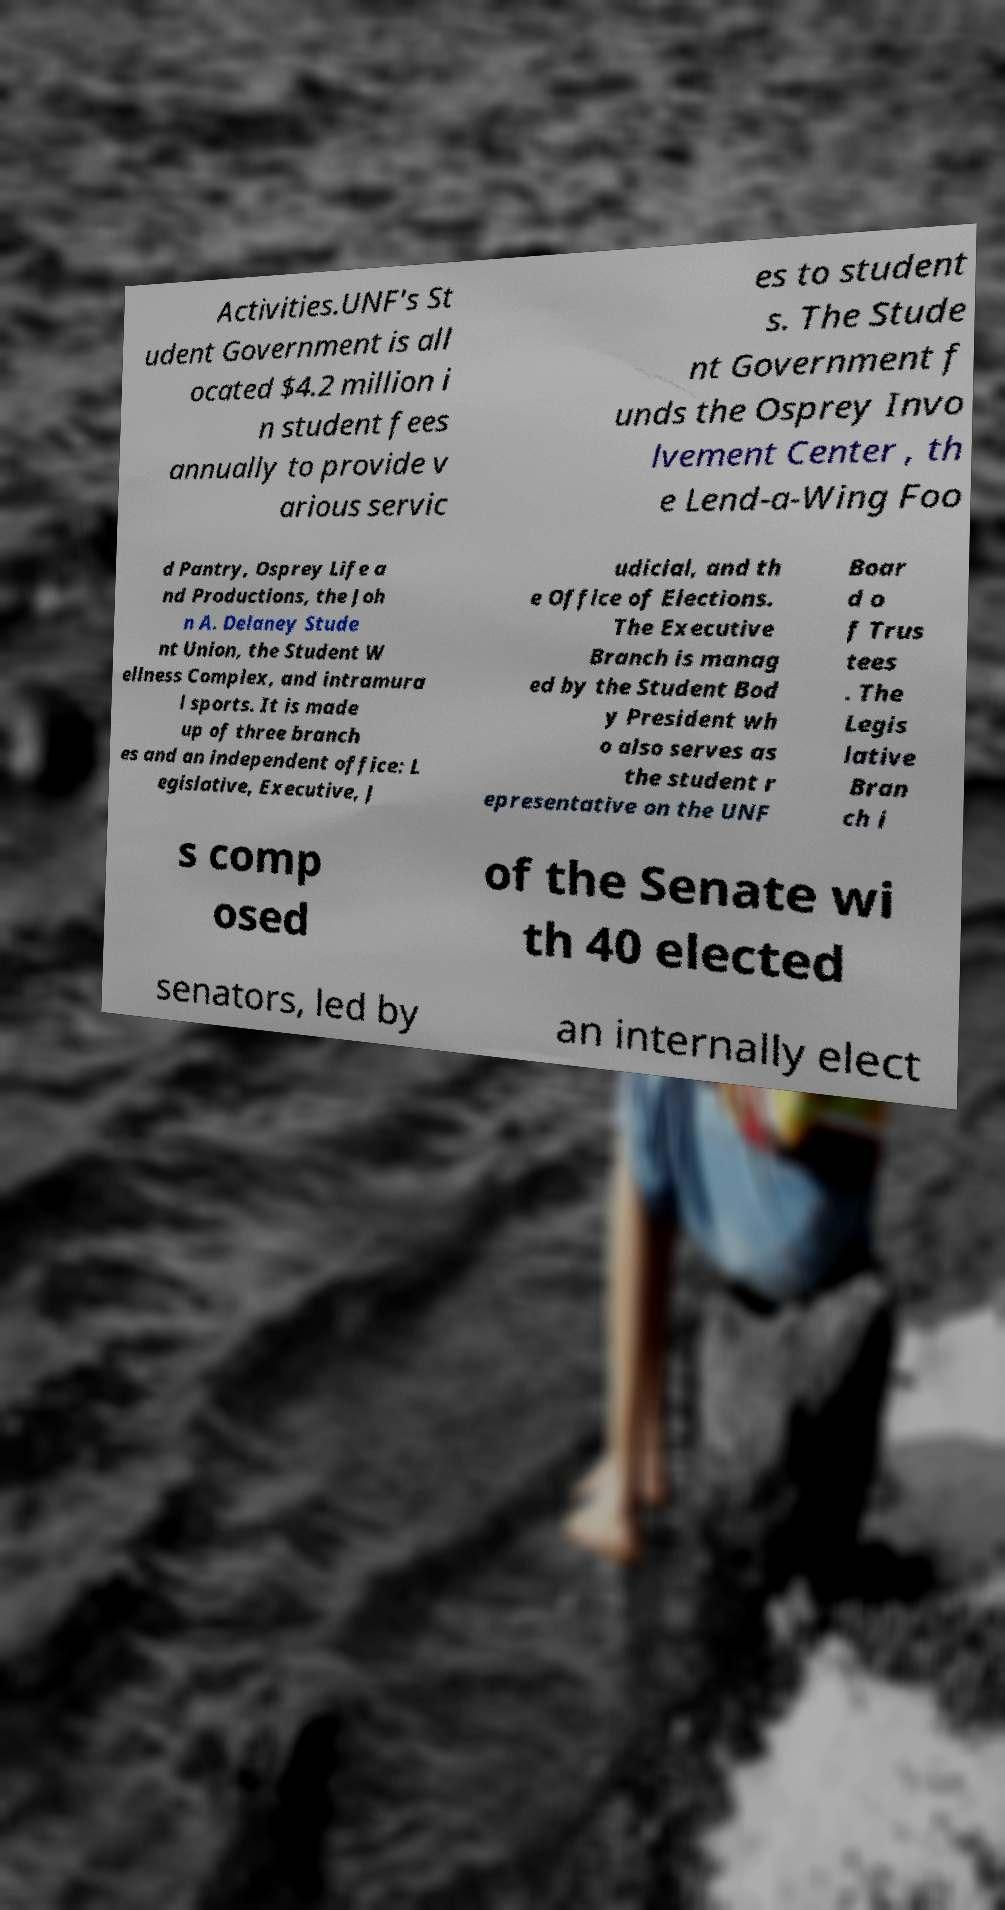There's text embedded in this image that I need extracted. Can you transcribe it verbatim? Activities.UNF's St udent Government is all ocated $4.2 million i n student fees annually to provide v arious servic es to student s. The Stude nt Government f unds the Osprey Invo lvement Center , th e Lend-a-Wing Foo d Pantry, Osprey Life a nd Productions, the Joh n A. Delaney Stude nt Union, the Student W ellness Complex, and intramura l sports. It is made up of three branch es and an independent office: L egislative, Executive, J udicial, and th e Office of Elections. The Executive Branch is manag ed by the Student Bod y President wh o also serves as the student r epresentative on the UNF Boar d o f Trus tees . The Legis lative Bran ch i s comp osed of the Senate wi th 40 elected senators, led by an internally elect 